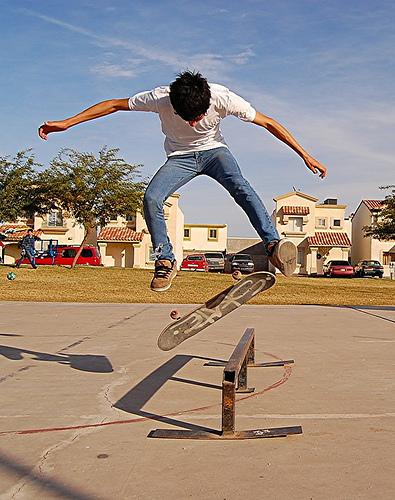Is the man looking at the sky?
Keep it brief. No. What elements of the photo are casting a shadow?
Quick response, please. Boy skateboard structure under boy. Is he a good skater?
Give a very brief answer. Yes. 